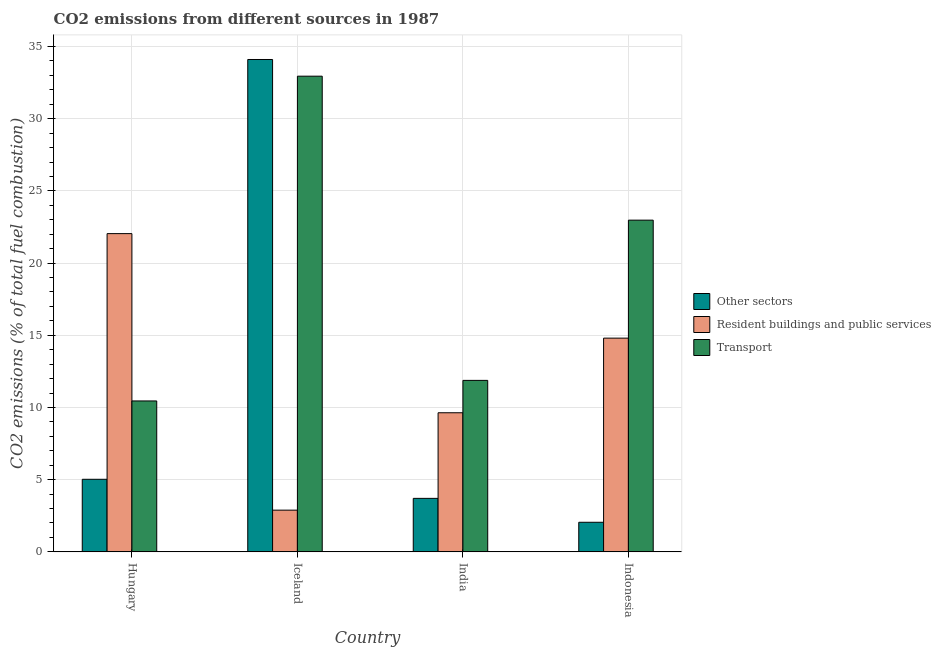How many groups of bars are there?
Make the answer very short. 4. Are the number of bars per tick equal to the number of legend labels?
Keep it short and to the point. Yes. Are the number of bars on each tick of the X-axis equal?
Your answer should be compact. Yes. How many bars are there on the 4th tick from the left?
Offer a very short reply. 3. How many bars are there on the 1st tick from the right?
Make the answer very short. 3. What is the label of the 1st group of bars from the left?
Give a very brief answer. Hungary. What is the percentage of co2 emissions from resident buildings and public services in Hungary?
Make the answer very short. 22.04. Across all countries, what is the maximum percentage of co2 emissions from resident buildings and public services?
Provide a short and direct response. 22.04. Across all countries, what is the minimum percentage of co2 emissions from transport?
Offer a very short reply. 10.45. In which country was the percentage of co2 emissions from resident buildings and public services minimum?
Make the answer very short. Iceland. What is the total percentage of co2 emissions from resident buildings and public services in the graph?
Provide a short and direct response. 49.37. What is the difference between the percentage of co2 emissions from other sectors in India and that in Indonesia?
Provide a short and direct response. 1.66. What is the difference between the percentage of co2 emissions from transport in Indonesia and the percentage of co2 emissions from resident buildings and public services in India?
Offer a very short reply. 13.34. What is the average percentage of co2 emissions from other sectors per country?
Make the answer very short. 11.22. What is the difference between the percentage of co2 emissions from transport and percentage of co2 emissions from other sectors in Hungary?
Provide a succinct answer. 5.43. In how many countries, is the percentage of co2 emissions from other sectors greater than 1 %?
Offer a terse response. 4. What is the ratio of the percentage of co2 emissions from resident buildings and public services in Hungary to that in India?
Give a very brief answer. 2.29. Is the percentage of co2 emissions from transport in Hungary less than that in India?
Provide a succinct answer. Yes. Is the difference between the percentage of co2 emissions from transport in Hungary and Indonesia greater than the difference between the percentage of co2 emissions from resident buildings and public services in Hungary and Indonesia?
Your answer should be compact. No. What is the difference between the highest and the second highest percentage of co2 emissions from other sectors?
Keep it short and to the point. 29.08. What is the difference between the highest and the lowest percentage of co2 emissions from other sectors?
Provide a short and direct response. 32.05. What does the 1st bar from the left in India represents?
Ensure brevity in your answer.  Other sectors. What does the 1st bar from the right in India represents?
Make the answer very short. Transport. Is it the case that in every country, the sum of the percentage of co2 emissions from other sectors and percentage of co2 emissions from resident buildings and public services is greater than the percentage of co2 emissions from transport?
Give a very brief answer. No. Are all the bars in the graph horizontal?
Keep it short and to the point. No. How many countries are there in the graph?
Offer a very short reply. 4. What is the difference between two consecutive major ticks on the Y-axis?
Your response must be concise. 5. Does the graph contain any zero values?
Keep it short and to the point. No. How many legend labels are there?
Make the answer very short. 3. How are the legend labels stacked?
Make the answer very short. Vertical. What is the title of the graph?
Keep it short and to the point. CO2 emissions from different sources in 1987. What is the label or title of the Y-axis?
Ensure brevity in your answer.  CO2 emissions (% of total fuel combustion). What is the CO2 emissions (% of total fuel combustion) in Other sectors in Hungary?
Provide a succinct answer. 5.03. What is the CO2 emissions (% of total fuel combustion) in Resident buildings and public services in Hungary?
Ensure brevity in your answer.  22.04. What is the CO2 emissions (% of total fuel combustion) in Transport in Hungary?
Provide a short and direct response. 10.45. What is the CO2 emissions (% of total fuel combustion) in Other sectors in Iceland?
Your response must be concise. 34.1. What is the CO2 emissions (% of total fuel combustion) of Resident buildings and public services in Iceland?
Your response must be concise. 2.89. What is the CO2 emissions (% of total fuel combustion) in Transport in Iceland?
Provide a short and direct response. 32.95. What is the CO2 emissions (% of total fuel combustion) of Other sectors in India?
Offer a very short reply. 3.71. What is the CO2 emissions (% of total fuel combustion) in Resident buildings and public services in India?
Provide a succinct answer. 9.64. What is the CO2 emissions (% of total fuel combustion) of Transport in India?
Provide a succinct answer. 11.88. What is the CO2 emissions (% of total fuel combustion) of Other sectors in Indonesia?
Give a very brief answer. 2.05. What is the CO2 emissions (% of total fuel combustion) of Resident buildings and public services in Indonesia?
Offer a terse response. 14.8. What is the CO2 emissions (% of total fuel combustion) in Transport in Indonesia?
Your answer should be very brief. 22.98. Across all countries, what is the maximum CO2 emissions (% of total fuel combustion) of Other sectors?
Make the answer very short. 34.1. Across all countries, what is the maximum CO2 emissions (% of total fuel combustion) of Resident buildings and public services?
Your answer should be very brief. 22.04. Across all countries, what is the maximum CO2 emissions (% of total fuel combustion) of Transport?
Your answer should be very brief. 32.95. Across all countries, what is the minimum CO2 emissions (% of total fuel combustion) of Other sectors?
Your answer should be compact. 2.05. Across all countries, what is the minimum CO2 emissions (% of total fuel combustion) of Resident buildings and public services?
Keep it short and to the point. 2.89. Across all countries, what is the minimum CO2 emissions (% of total fuel combustion) of Transport?
Ensure brevity in your answer.  10.45. What is the total CO2 emissions (% of total fuel combustion) in Other sectors in the graph?
Provide a succinct answer. 44.89. What is the total CO2 emissions (% of total fuel combustion) in Resident buildings and public services in the graph?
Make the answer very short. 49.37. What is the total CO2 emissions (% of total fuel combustion) in Transport in the graph?
Give a very brief answer. 78.26. What is the difference between the CO2 emissions (% of total fuel combustion) of Other sectors in Hungary and that in Iceland?
Your answer should be compact. -29.08. What is the difference between the CO2 emissions (% of total fuel combustion) in Resident buildings and public services in Hungary and that in Iceland?
Keep it short and to the point. 19.15. What is the difference between the CO2 emissions (% of total fuel combustion) in Transport in Hungary and that in Iceland?
Your answer should be very brief. -22.49. What is the difference between the CO2 emissions (% of total fuel combustion) of Other sectors in Hungary and that in India?
Offer a terse response. 1.32. What is the difference between the CO2 emissions (% of total fuel combustion) of Resident buildings and public services in Hungary and that in India?
Offer a terse response. 12.41. What is the difference between the CO2 emissions (% of total fuel combustion) in Transport in Hungary and that in India?
Your response must be concise. -1.42. What is the difference between the CO2 emissions (% of total fuel combustion) of Other sectors in Hungary and that in Indonesia?
Provide a short and direct response. 2.98. What is the difference between the CO2 emissions (% of total fuel combustion) in Resident buildings and public services in Hungary and that in Indonesia?
Make the answer very short. 7.24. What is the difference between the CO2 emissions (% of total fuel combustion) in Transport in Hungary and that in Indonesia?
Provide a short and direct response. -12.52. What is the difference between the CO2 emissions (% of total fuel combustion) of Other sectors in Iceland and that in India?
Offer a terse response. 30.4. What is the difference between the CO2 emissions (% of total fuel combustion) of Resident buildings and public services in Iceland and that in India?
Offer a terse response. -6.75. What is the difference between the CO2 emissions (% of total fuel combustion) in Transport in Iceland and that in India?
Keep it short and to the point. 21.07. What is the difference between the CO2 emissions (% of total fuel combustion) in Other sectors in Iceland and that in Indonesia?
Give a very brief answer. 32.05. What is the difference between the CO2 emissions (% of total fuel combustion) in Resident buildings and public services in Iceland and that in Indonesia?
Your answer should be very brief. -11.91. What is the difference between the CO2 emissions (% of total fuel combustion) of Transport in Iceland and that in Indonesia?
Make the answer very short. 9.97. What is the difference between the CO2 emissions (% of total fuel combustion) of Other sectors in India and that in Indonesia?
Keep it short and to the point. 1.66. What is the difference between the CO2 emissions (% of total fuel combustion) of Resident buildings and public services in India and that in Indonesia?
Make the answer very short. -5.17. What is the difference between the CO2 emissions (% of total fuel combustion) in Transport in India and that in Indonesia?
Your answer should be very brief. -11.1. What is the difference between the CO2 emissions (% of total fuel combustion) in Other sectors in Hungary and the CO2 emissions (% of total fuel combustion) in Resident buildings and public services in Iceland?
Your answer should be very brief. 2.14. What is the difference between the CO2 emissions (% of total fuel combustion) in Other sectors in Hungary and the CO2 emissions (% of total fuel combustion) in Transport in Iceland?
Offer a terse response. -27.92. What is the difference between the CO2 emissions (% of total fuel combustion) in Resident buildings and public services in Hungary and the CO2 emissions (% of total fuel combustion) in Transport in Iceland?
Offer a very short reply. -10.9. What is the difference between the CO2 emissions (% of total fuel combustion) of Other sectors in Hungary and the CO2 emissions (% of total fuel combustion) of Resident buildings and public services in India?
Your answer should be compact. -4.61. What is the difference between the CO2 emissions (% of total fuel combustion) of Other sectors in Hungary and the CO2 emissions (% of total fuel combustion) of Transport in India?
Your answer should be very brief. -6.85. What is the difference between the CO2 emissions (% of total fuel combustion) in Resident buildings and public services in Hungary and the CO2 emissions (% of total fuel combustion) in Transport in India?
Give a very brief answer. 10.17. What is the difference between the CO2 emissions (% of total fuel combustion) in Other sectors in Hungary and the CO2 emissions (% of total fuel combustion) in Resident buildings and public services in Indonesia?
Your answer should be very brief. -9.78. What is the difference between the CO2 emissions (% of total fuel combustion) of Other sectors in Hungary and the CO2 emissions (% of total fuel combustion) of Transport in Indonesia?
Make the answer very short. -17.95. What is the difference between the CO2 emissions (% of total fuel combustion) of Resident buildings and public services in Hungary and the CO2 emissions (% of total fuel combustion) of Transport in Indonesia?
Give a very brief answer. -0.93. What is the difference between the CO2 emissions (% of total fuel combustion) in Other sectors in Iceland and the CO2 emissions (% of total fuel combustion) in Resident buildings and public services in India?
Your answer should be compact. 24.47. What is the difference between the CO2 emissions (% of total fuel combustion) in Other sectors in Iceland and the CO2 emissions (% of total fuel combustion) in Transport in India?
Provide a succinct answer. 22.23. What is the difference between the CO2 emissions (% of total fuel combustion) in Resident buildings and public services in Iceland and the CO2 emissions (% of total fuel combustion) in Transport in India?
Your answer should be very brief. -8.99. What is the difference between the CO2 emissions (% of total fuel combustion) of Other sectors in Iceland and the CO2 emissions (% of total fuel combustion) of Resident buildings and public services in Indonesia?
Ensure brevity in your answer.  19.3. What is the difference between the CO2 emissions (% of total fuel combustion) of Other sectors in Iceland and the CO2 emissions (% of total fuel combustion) of Transport in Indonesia?
Keep it short and to the point. 11.13. What is the difference between the CO2 emissions (% of total fuel combustion) in Resident buildings and public services in Iceland and the CO2 emissions (% of total fuel combustion) in Transport in Indonesia?
Offer a very short reply. -20.09. What is the difference between the CO2 emissions (% of total fuel combustion) in Other sectors in India and the CO2 emissions (% of total fuel combustion) in Resident buildings and public services in Indonesia?
Offer a very short reply. -11.1. What is the difference between the CO2 emissions (% of total fuel combustion) of Other sectors in India and the CO2 emissions (% of total fuel combustion) of Transport in Indonesia?
Give a very brief answer. -19.27. What is the difference between the CO2 emissions (% of total fuel combustion) of Resident buildings and public services in India and the CO2 emissions (% of total fuel combustion) of Transport in Indonesia?
Offer a very short reply. -13.34. What is the average CO2 emissions (% of total fuel combustion) in Other sectors per country?
Offer a terse response. 11.22. What is the average CO2 emissions (% of total fuel combustion) in Resident buildings and public services per country?
Provide a succinct answer. 12.34. What is the average CO2 emissions (% of total fuel combustion) in Transport per country?
Offer a terse response. 19.56. What is the difference between the CO2 emissions (% of total fuel combustion) of Other sectors and CO2 emissions (% of total fuel combustion) of Resident buildings and public services in Hungary?
Your answer should be compact. -17.02. What is the difference between the CO2 emissions (% of total fuel combustion) of Other sectors and CO2 emissions (% of total fuel combustion) of Transport in Hungary?
Provide a short and direct response. -5.43. What is the difference between the CO2 emissions (% of total fuel combustion) in Resident buildings and public services and CO2 emissions (% of total fuel combustion) in Transport in Hungary?
Make the answer very short. 11.59. What is the difference between the CO2 emissions (% of total fuel combustion) in Other sectors and CO2 emissions (% of total fuel combustion) in Resident buildings and public services in Iceland?
Your answer should be very brief. 31.21. What is the difference between the CO2 emissions (% of total fuel combustion) in Other sectors and CO2 emissions (% of total fuel combustion) in Transport in Iceland?
Offer a very short reply. 1.16. What is the difference between the CO2 emissions (% of total fuel combustion) of Resident buildings and public services and CO2 emissions (% of total fuel combustion) of Transport in Iceland?
Provide a short and direct response. -30.06. What is the difference between the CO2 emissions (% of total fuel combustion) of Other sectors and CO2 emissions (% of total fuel combustion) of Resident buildings and public services in India?
Provide a short and direct response. -5.93. What is the difference between the CO2 emissions (% of total fuel combustion) of Other sectors and CO2 emissions (% of total fuel combustion) of Transport in India?
Offer a very short reply. -8.17. What is the difference between the CO2 emissions (% of total fuel combustion) in Resident buildings and public services and CO2 emissions (% of total fuel combustion) in Transport in India?
Your response must be concise. -2.24. What is the difference between the CO2 emissions (% of total fuel combustion) of Other sectors and CO2 emissions (% of total fuel combustion) of Resident buildings and public services in Indonesia?
Keep it short and to the point. -12.76. What is the difference between the CO2 emissions (% of total fuel combustion) of Other sectors and CO2 emissions (% of total fuel combustion) of Transport in Indonesia?
Provide a short and direct response. -20.93. What is the difference between the CO2 emissions (% of total fuel combustion) in Resident buildings and public services and CO2 emissions (% of total fuel combustion) in Transport in Indonesia?
Offer a very short reply. -8.17. What is the ratio of the CO2 emissions (% of total fuel combustion) in Other sectors in Hungary to that in Iceland?
Offer a terse response. 0.15. What is the ratio of the CO2 emissions (% of total fuel combustion) of Resident buildings and public services in Hungary to that in Iceland?
Provide a succinct answer. 7.63. What is the ratio of the CO2 emissions (% of total fuel combustion) in Transport in Hungary to that in Iceland?
Provide a short and direct response. 0.32. What is the ratio of the CO2 emissions (% of total fuel combustion) of Other sectors in Hungary to that in India?
Your answer should be compact. 1.36. What is the ratio of the CO2 emissions (% of total fuel combustion) of Resident buildings and public services in Hungary to that in India?
Keep it short and to the point. 2.29. What is the ratio of the CO2 emissions (% of total fuel combustion) of Transport in Hungary to that in India?
Provide a short and direct response. 0.88. What is the ratio of the CO2 emissions (% of total fuel combustion) of Other sectors in Hungary to that in Indonesia?
Provide a succinct answer. 2.45. What is the ratio of the CO2 emissions (% of total fuel combustion) of Resident buildings and public services in Hungary to that in Indonesia?
Give a very brief answer. 1.49. What is the ratio of the CO2 emissions (% of total fuel combustion) in Transport in Hungary to that in Indonesia?
Offer a very short reply. 0.46. What is the ratio of the CO2 emissions (% of total fuel combustion) of Other sectors in Iceland to that in India?
Give a very brief answer. 9.2. What is the ratio of the CO2 emissions (% of total fuel combustion) of Resident buildings and public services in Iceland to that in India?
Provide a short and direct response. 0.3. What is the ratio of the CO2 emissions (% of total fuel combustion) of Transport in Iceland to that in India?
Give a very brief answer. 2.77. What is the ratio of the CO2 emissions (% of total fuel combustion) in Other sectors in Iceland to that in Indonesia?
Offer a very short reply. 16.64. What is the ratio of the CO2 emissions (% of total fuel combustion) in Resident buildings and public services in Iceland to that in Indonesia?
Keep it short and to the point. 0.2. What is the ratio of the CO2 emissions (% of total fuel combustion) of Transport in Iceland to that in Indonesia?
Make the answer very short. 1.43. What is the ratio of the CO2 emissions (% of total fuel combustion) of Other sectors in India to that in Indonesia?
Make the answer very short. 1.81. What is the ratio of the CO2 emissions (% of total fuel combustion) in Resident buildings and public services in India to that in Indonesia?
Provide a short and direct response. 0.65. What is the ratio of the CO2 emissions (% of total fuel combustion) of Transport in India to that in Indonesia?
Offer a very short reply. 0.52. What is the difference between the highest and the second highest CO2 emissions (% of total fuel combustion) of Other sectors?
Make the answer very short. 29.08. What is the difference between the highest and the second highest CO2 emissions (% of total fuel combustion) in Resident buildings and public services?
Offer a very short reply. 7.24. What is the difference between the highest and the second highest CO2 emissions (% of total fuel combustion) in Transport?
Make the answer very short. 9.97. What is the difference between the highest and the lowest CO2 emissions (% of total fuel combustion) of Other sectors?
Your answer should be compact. 32.05. What is the difference between the highest and the lowest CO2 emissions (% of total fuel combustion) of Resident buildings and public services?
Your answer should be compact. 19.15. What is the difference between the highest and the lowest CO2 emissions (% of total fuel combustion) of Transport?
Your answer should be very brief. 22.49. 